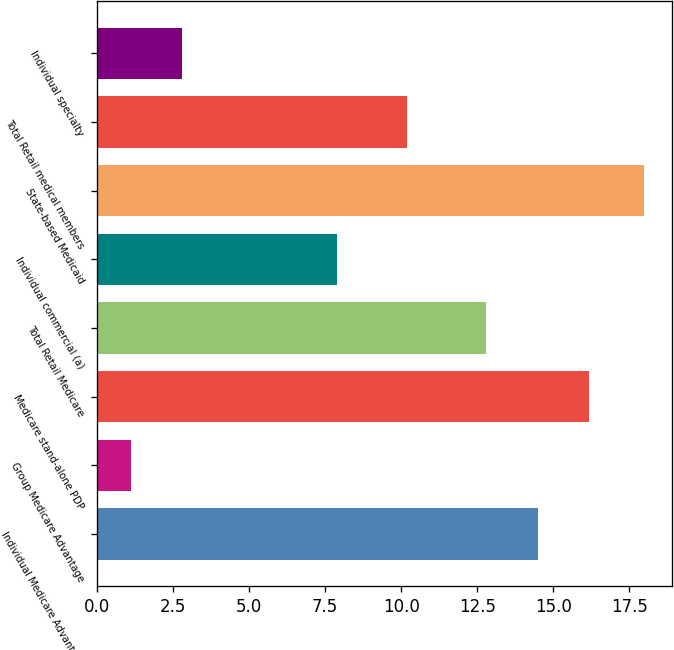Convert chart. <chart><loc_0><loc_0><loc_500><loc_500><bar_chart><fcel>Individual Medicare Advantage<fcel>Group Medicare Advantage<fcel>Medicare stand-alone PDP<fcel>Total Retail Medicare<fcel>Individual commercial (a)<fcel>State-based Medicaid<fcel>Total Retail medical members<fcel>Individual specialty<nl><fcel>14.49<fcel>1.1<fcel>16.18<fcel>12.8<fcel>7.9<fcel>18<fcel>10.2<fcel>2.79<nl></chart> 